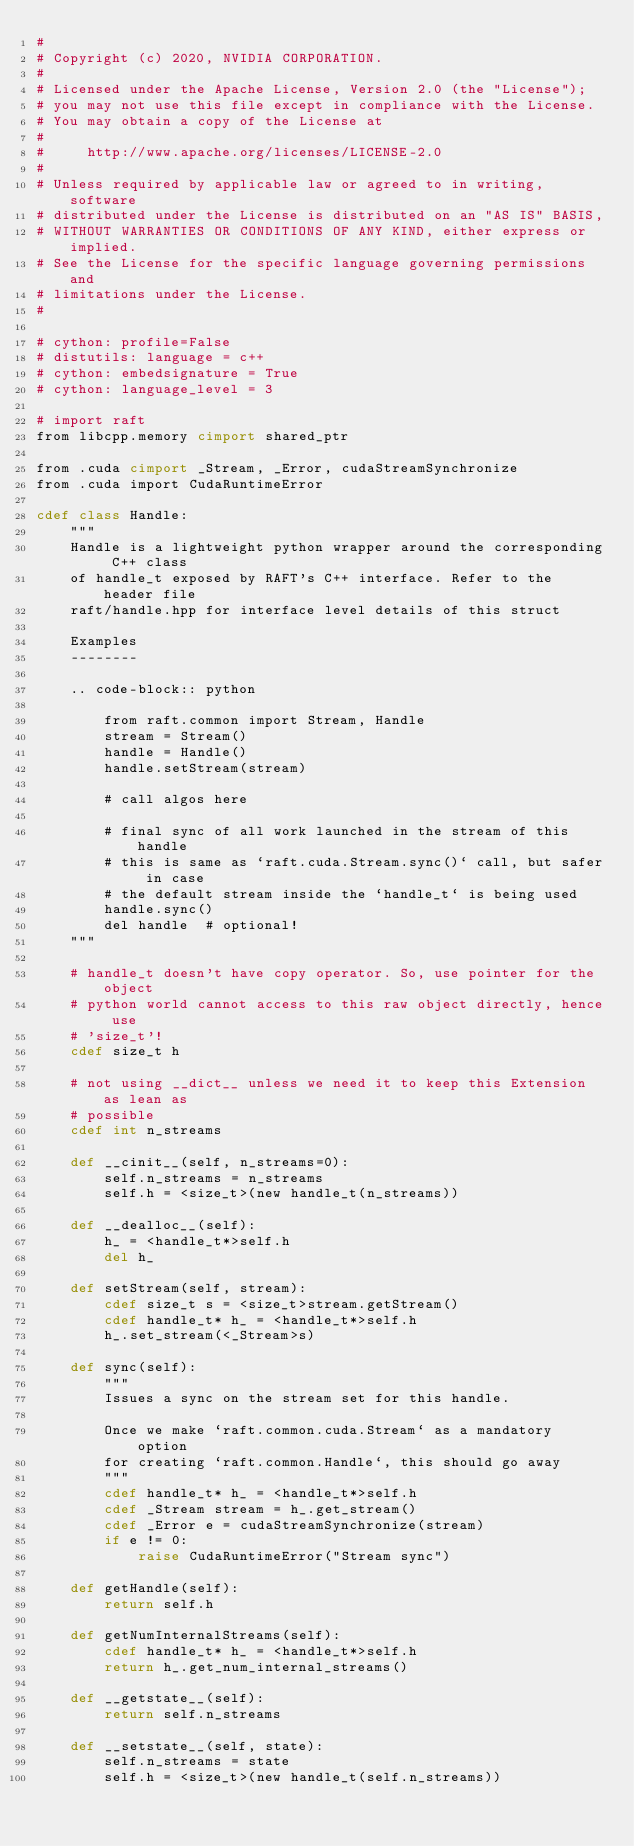<code> <loc_0><loc_0><loc_500><loc_500><_Cython_>#
# Copyright (c) 2020, NVIDIA CORPORATION.
#
# Licensed under the Apache License, Version 2.0 (the "License");
# you may not use this file except in compliance with the License.
# You may obtain a copy of the License at
#
#     http://www.apache.org/licenses/LICENSE-2.0
#
# Unless required by applicable law or agreed to in writing, software
# distributed under the License is distributed on an "AS IS" BASIS,
# WITHOUT WARRANTIES OR CONDITIONS OF ANY KIND, either express or implied.
# See the License for the specific language governing permissions and
# limitations under the License.
#

# cython: profile=False
# distutils: language = c++
# cython: embedsignature = True
# cython: language_level = 3

# import raft
from libcpp.memory cimport shared_ptr

from .cuda cimport _Stream, _Error, cudaStreamSynchronize
from .cuda import CudaRuntimeError

cdef class Handle:
    """
    Handle is a lightweight python wrapper around the corresponding C++ class
    of handle_t exposed by RAFT's C++ interface. Refer to the header file
    raft/handle.hpp for interface level details of this struct

    Examples
    --------

    .. code-block:: python

        from raft.common import Stream, Handle
        stream = Stream()
        handle = Handle()
        handle.setStream(stream)

        # call algos here

        # final sync of all work launched in the stream of this handle
        # this is same as `raft.cuda.Stream.sync()` call, but safer in case
        # the default stream inside the `handle_t` is being used
        handle.sync()
        del handle  # optional!
    """

    # handle_t doesn't have copy operator. So, use pointer for the object
    # python world cannot access to this raw object directly, hence use
    # 'size_t'!
    cdef size_t h

    # not using __dict__ unless we need it to keep this Extension as lean as
    # possible
    cdef int n_streams

    def __cinit__(self, n_streams=0):
        self.n_streams = n_streams
        self.h = <size_t>(new handle_t(n_streams))

    def __dealloc__(self):
        h_ = <handle_t*>self.h
        del h_

    def setStream(self, stream):
        cdef size_t s = <size_t>stream.getStream()
        cdef handle_t* h_ = <handle_t*>self.h
        h_.set_stream(<_Stream>s)

    def sync(self):
        """
        Issues a sync on the stream set for this handle.

        Once we make `raft.common.cuda.Stream` as a mandatory option
        for creating `raft.common.Handle`, this should go away
        """
        cdef handle_t* h_ = <handle_t*>self.h
        cdef _Stream stream = h_.get_stream()
        cdef _Error e = cudaStreamSynchronize(stream)
        if e != 0:
            raise CudaRuntimeError("Stream sync")

    def getHandle(self):
        return self.h

    def getNumInternalStreams(self):
        cdef handle_t* h_ = <handle_t*>self.h
        return h_.get_num_internal_streams()

    def __getstate__(self):
        return self.n_streams

    def __setstate__(self, state):
        self.n_streams = state
        self.h = <size_t>(new handle_t(self.n_streams))
</code> 